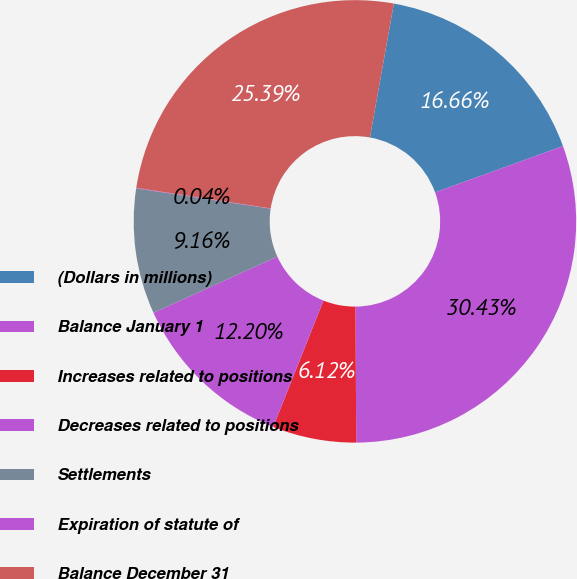Convert chart. <chart><loc_0><loc_0><loc_500><loc_500><pie_chart><fcel>(Dollars in millions)<fcel>Balance January 1<fcel>Increases related to positions<fcel>Decreases related to positions<fcel>Settlements<fcel>Expiration of statute of<fcel>Balance December 31<nl><fcel>16.66%<fcel>30.43%<fcel>6.12%<fcel>12.2%<fcel>9.16%<fcel>0.04%<fcel>25.39%<nl></chart> 